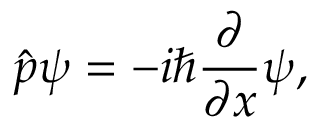<formula> <loc_0><loc_0><loc_500><loc_500>{ \hat { p } } \psi = - i \hbar { \frac { \partial } { \partial x } } \psi ,</formula> 